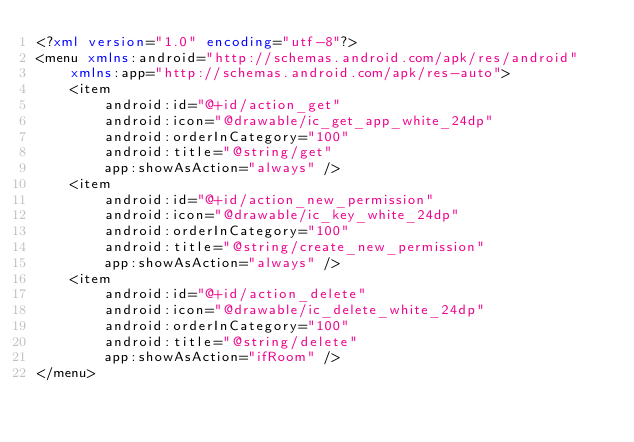Convert code to text. <code><loc_0><loc_0><loc_500><loc_500><_XML_><?xml version="1.0" encoding="utf-8"?>
<menu xmlns:android="http://schemas.android.com/apk/res/android"
    xmlns:app="http://schemas.android.com/apk/res-auto">
    <item
        android:id="@+id/action_get"
        android:icon="@drawable/ic_get_app_white_24dp"
        android:orderInCategory="100"
        android:title="@string/get"
        app:showAsAction="always" />
    <item
        android:id="@+id/action_new_permission"
        android:icon="@drawable/ic_key_white_24dp"
        android:orderInCategory="100"
        android:title="@string/create_new_permission"
        app:showAsAction="always" />
    <item
        android:id="@+id/action_delete"
        android:icon="@drawable/ic_delete_white_24dp"
        android:orderInCategory="100"
        android:title="@string/delete"
        app:showAsAction="ifRoom" />
</menu></code> 